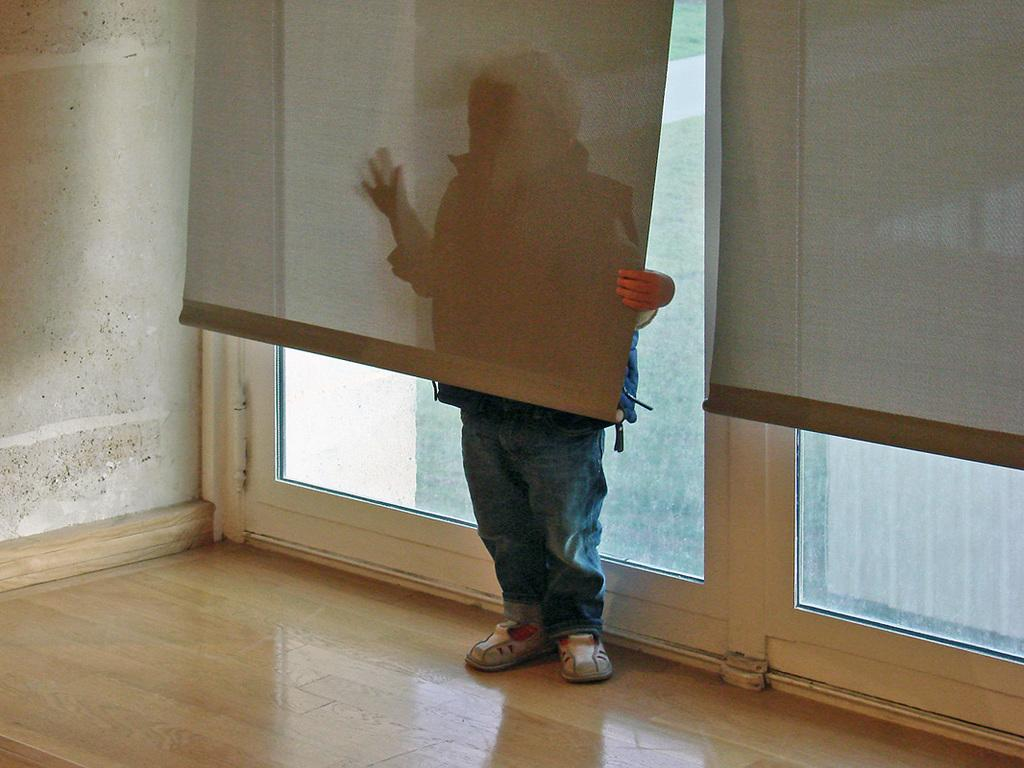Who is present in the image? There is a man in the image. What is the man doing in the image? The man is hiding behind blinds. What can be seen in the background of the image? There are windows and walls in the background of the image. What is the surface on which the man is standing? There is a floor visible in the image. What type of pain is the man experiencing in the image? There is no indication of pain in the image; the man is simply hiding behind blinds. What kind of bottle is the man holding in the image? There is no bottle present in the image. 